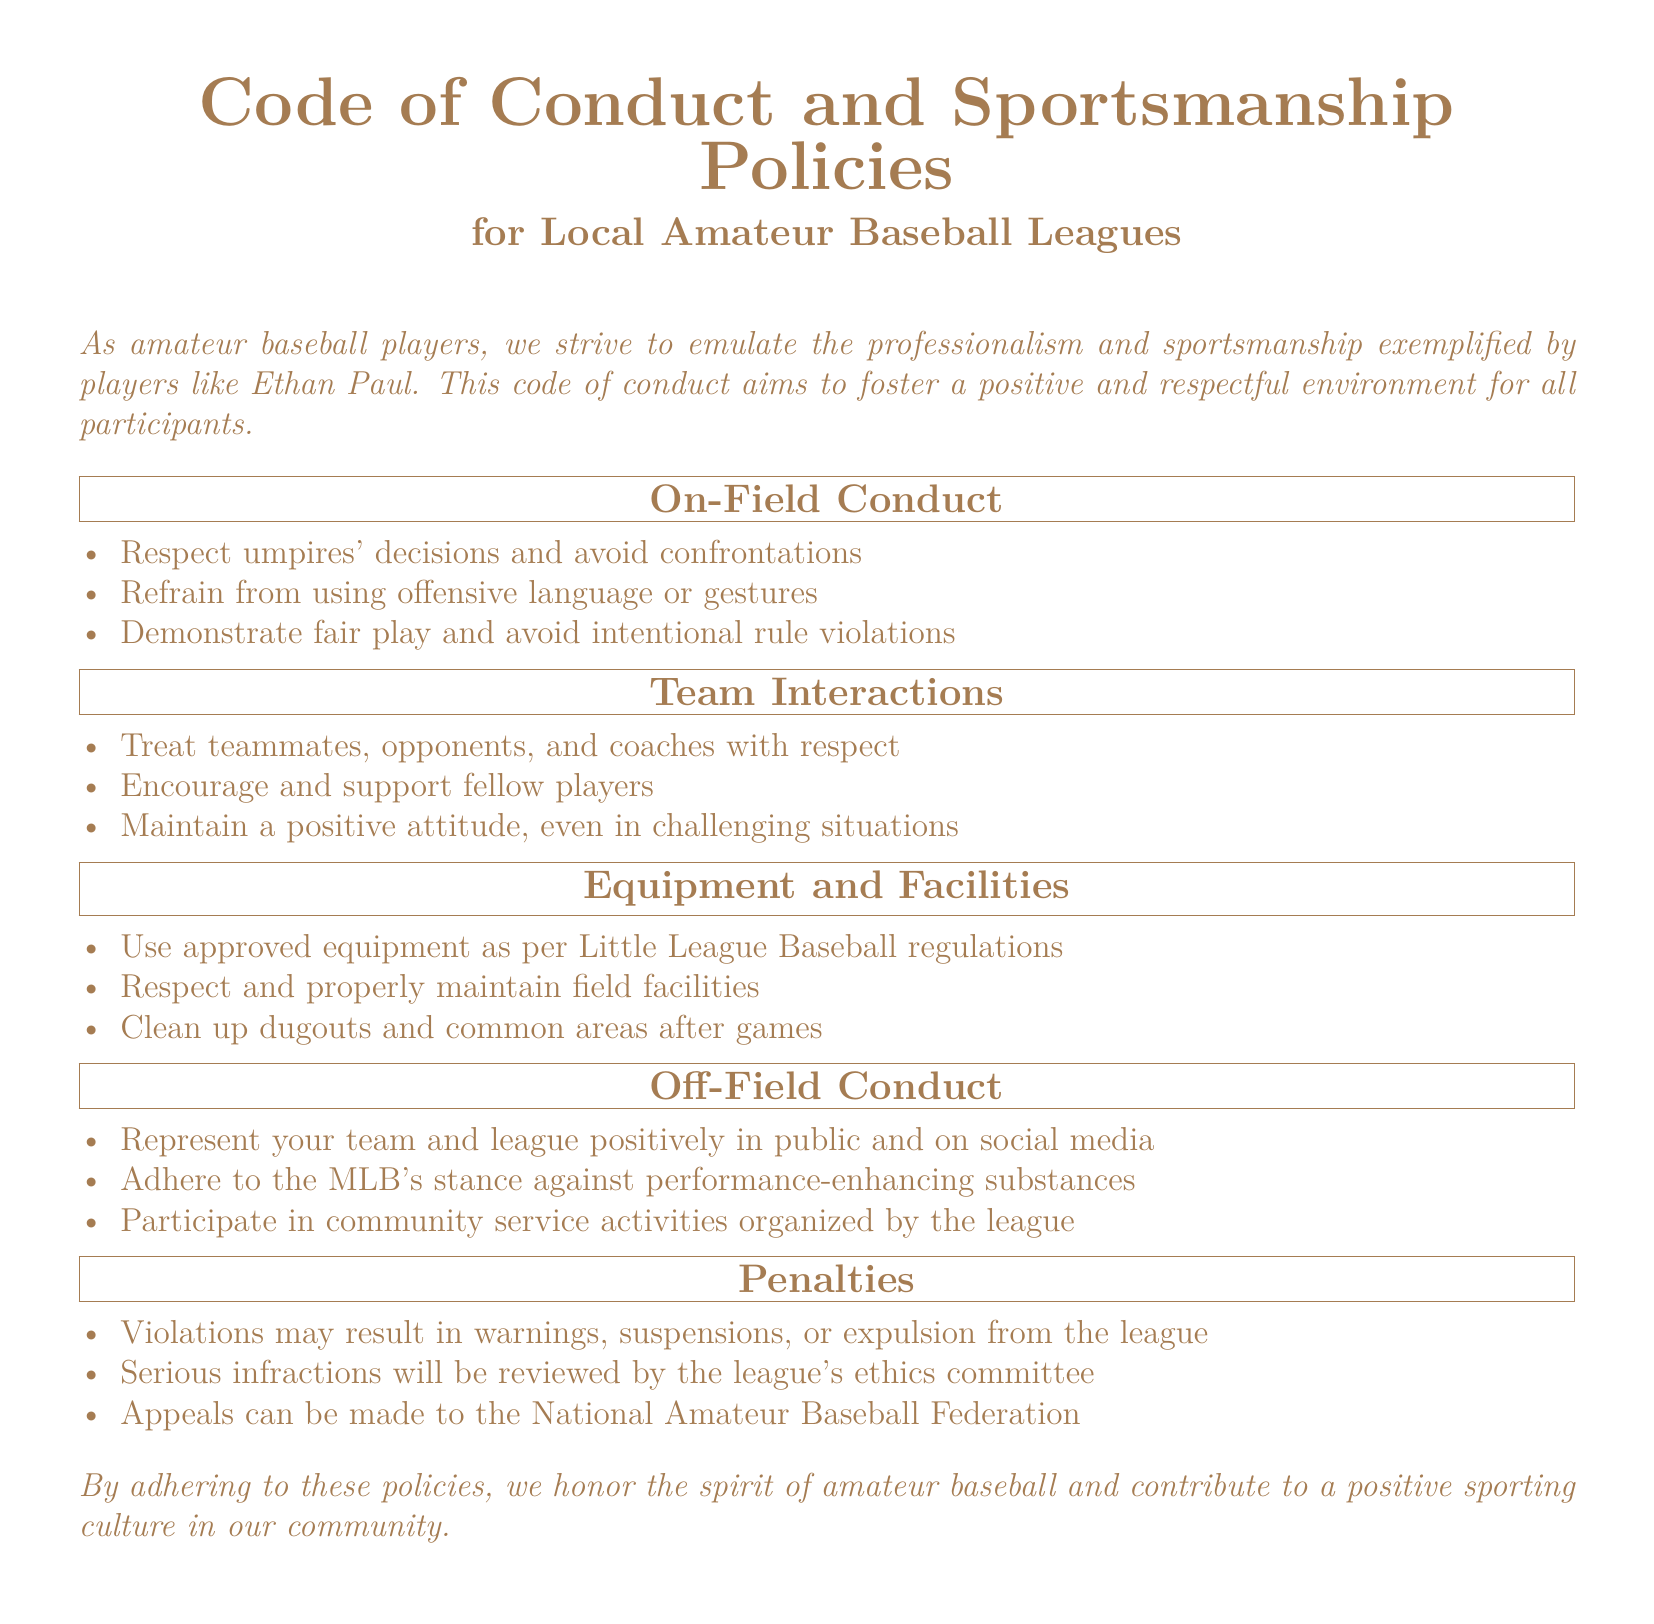What is the title of the document? The title is prominently displayed at the top of the document, which indicates the subject matter.
Answer: Code of Conduct and Sportsmanship Policies What does the document emphasize for players? The introductory statement reflects the document's central theme regarding player behavior and community values.
Answer: Professionalism and sportsmanship What must players respect according to the On-Field Conduct section? This question focuses on one of the key elements outlined in the document regarding player behavior during games.
Answer: Umpires' decisions What should players do in challenging situations according to Team Interactions? This question is derived from the collective ideas presented in the Team Interactions section, focusing on attitude.
Answer: Maintain a positive attitude What type of equipment must be used? This question is about the specific requirements mentioned in the Equipment and Facilities section regarding player gear.
Answer: Approved equipment What may serious infractions lead to? The question looks for consequences outlined in the Penalties section, indicating severity of misconduct.
Answer: Review by the league's ethics committee What does off-field conduct include regarding social media? This question examines the Off-Field Conduct section criteria about general behavior outside games.
Answer: Represent positively What can individuals appeal to in case of penalties? The question asks for the body that handles appeals as per the outlined penalties.
Answer: National Amateur Baseball Federation How are violations generally managed according to the document? This involves understanding how infractions are dealt with as noted in the penalties section.
Answer: Warnings, suspensions, or expulsion 